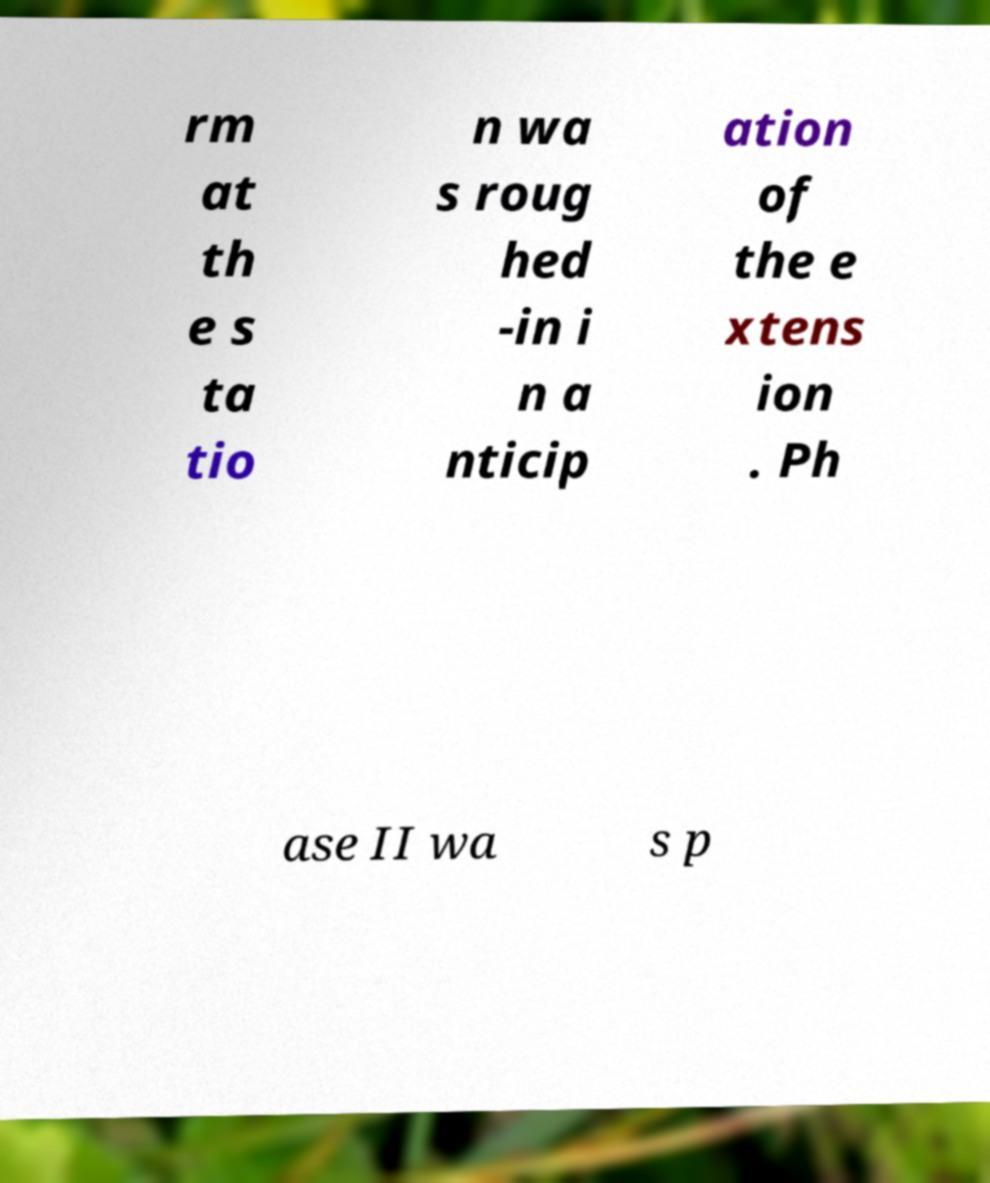What messages or text are displayed in this image? I need them in a readable, typed format. rm at th e s ta tio n wa s roug hed -in i n a nticip ation of the e xtens ion . Ph ase II wa s p 